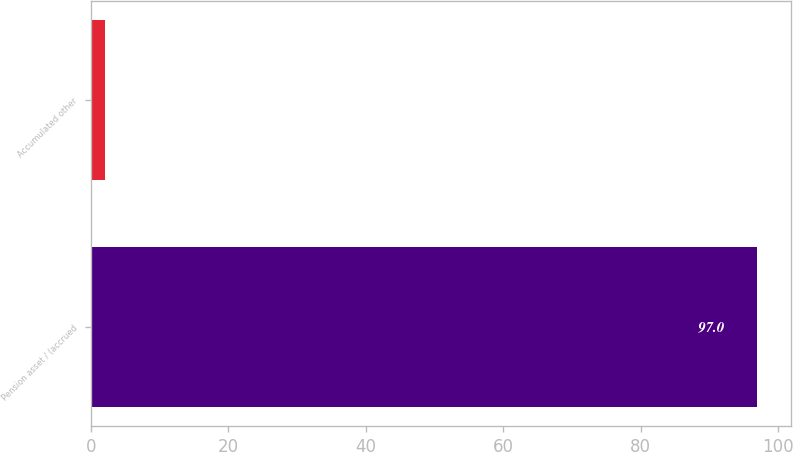Convert chart. <chart><loc_0><loc_0><loc_500><loc_500><bar_chart><fcel>Pension asset / (accrued<fcel>Accumulated other<nl><fcel>97<fcel>2<nl></chart> 